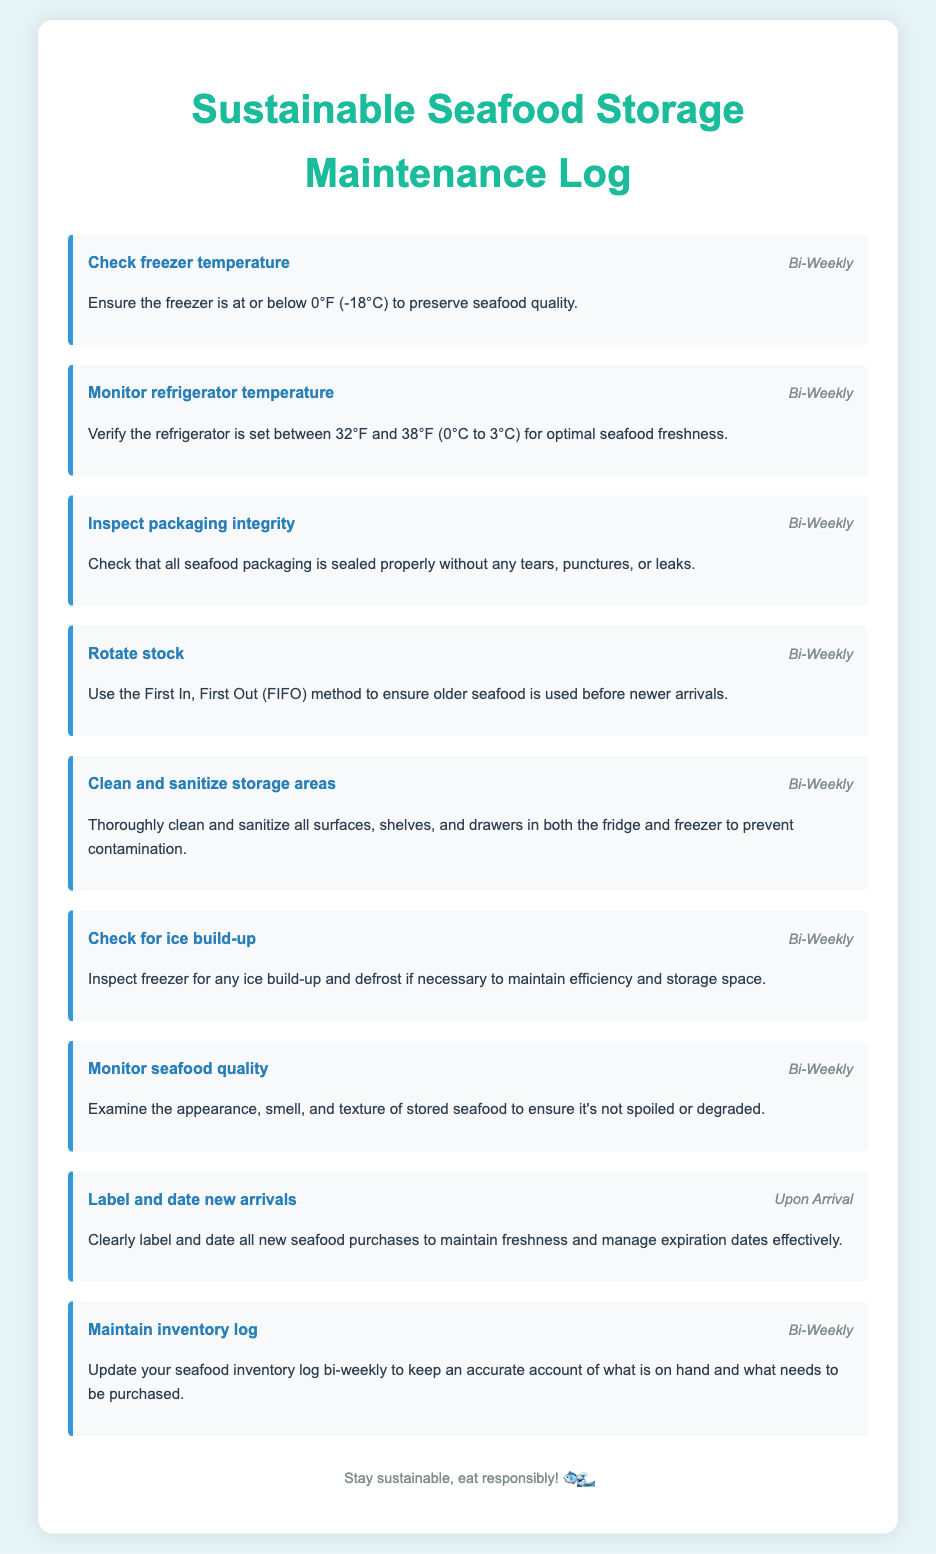what is the title of the document? The title of the document is displayed prominently at the top, indicating the purpose of the log.
Answer: Sustainable Seafood Storage Maintenance Log how often should the freezer temperature be checked? The document specifies the frequency of checking the freezer temperature as bi-weekly.
Answer: Bi-Weekly what is the optimal refrigerator temperature range for seafood? The document provides a specific temperature range for optimal seafood freshness in the refrigerator.
Answer: 32°F to 38°F which method should be used to rotate stock? The document refers to a specific method for stock rotation to ensure freshness.
Answer: First In, First Out (FIFO) when should new seafood arrivals be labeled and dated? The document indicates the specific time when new seafood should be managed for freshness.
Answer: Upon Arrival what should be inspected for ice build-up? The document specifies what needs to be examined for ice accumulation to maintain efficiency.
Answer: Freezer how should packaging integrity be checked? The document describes what to look for when inspecting the packaging of seafood.
Answer: Sealed properly without tears, punctures, or leaks what is the purpose of maintaining an inventory log? The document states the reason for updating the seafood inventory log regularly.
Answer: To keep an accurate account of what is on hand and what needs to be purchased what action should be taken if the freezer shows ice build-up? The document advises what action to take under specific conditions regarding ice accumulation.
Answer: Defrost if necessary 